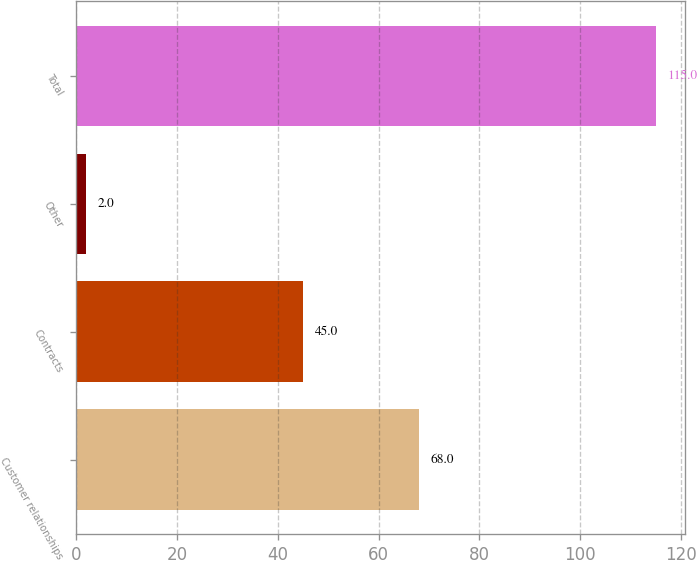Convert chart. <chart><loc_0><loc_0><loc_500><loc_500><bar_chart><fcel>Customer relationships<fcel>Contracts<fcel>Other<fcel>Total<nl><fcel>68<fcel>45<fcel>2<fcel>115<nl></chart> 